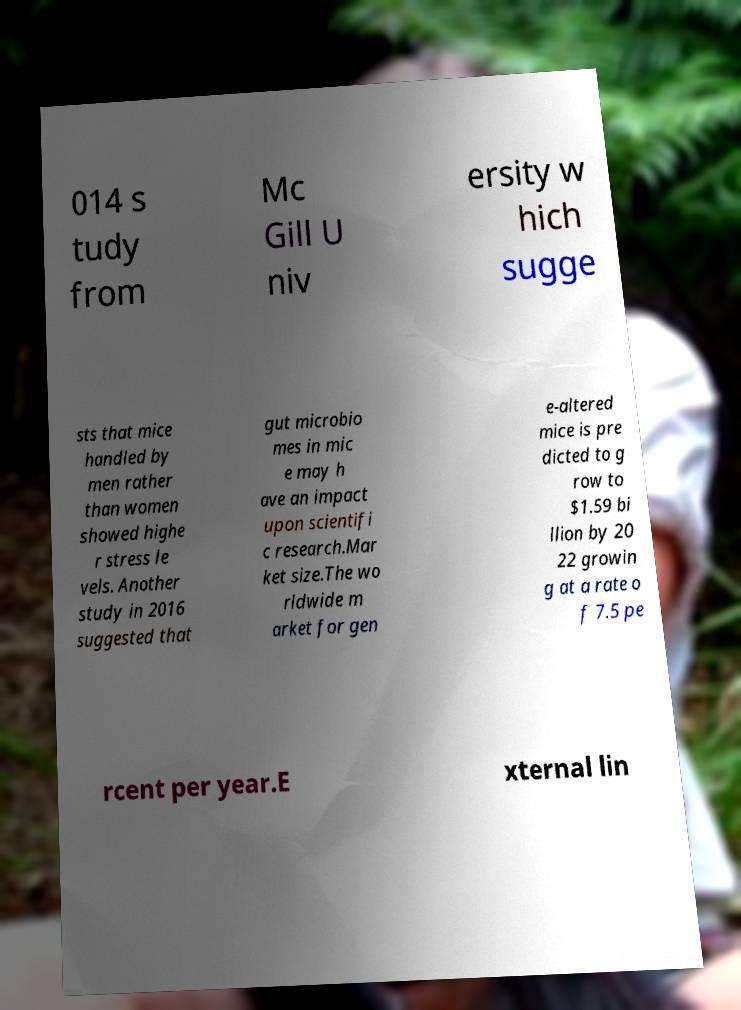Could you assist in decoding the text presented in this image and type it out clearly? 014 s tudy from Mc Gill U niv ersity w hich sugge sts that mice handled by men rather than women showed highe r stress le vels. Another study in 2016 suggested that gut microbio mes in mic e may h ave an impact upon scientifi c research.Mar ket size.The wo rldwide m arket for gen e-altered mice is pre dicted to g row to $1.59 bi llion by 20 22 growin g at a rate o f 7.5 pe rcent per year.E xternal lin 